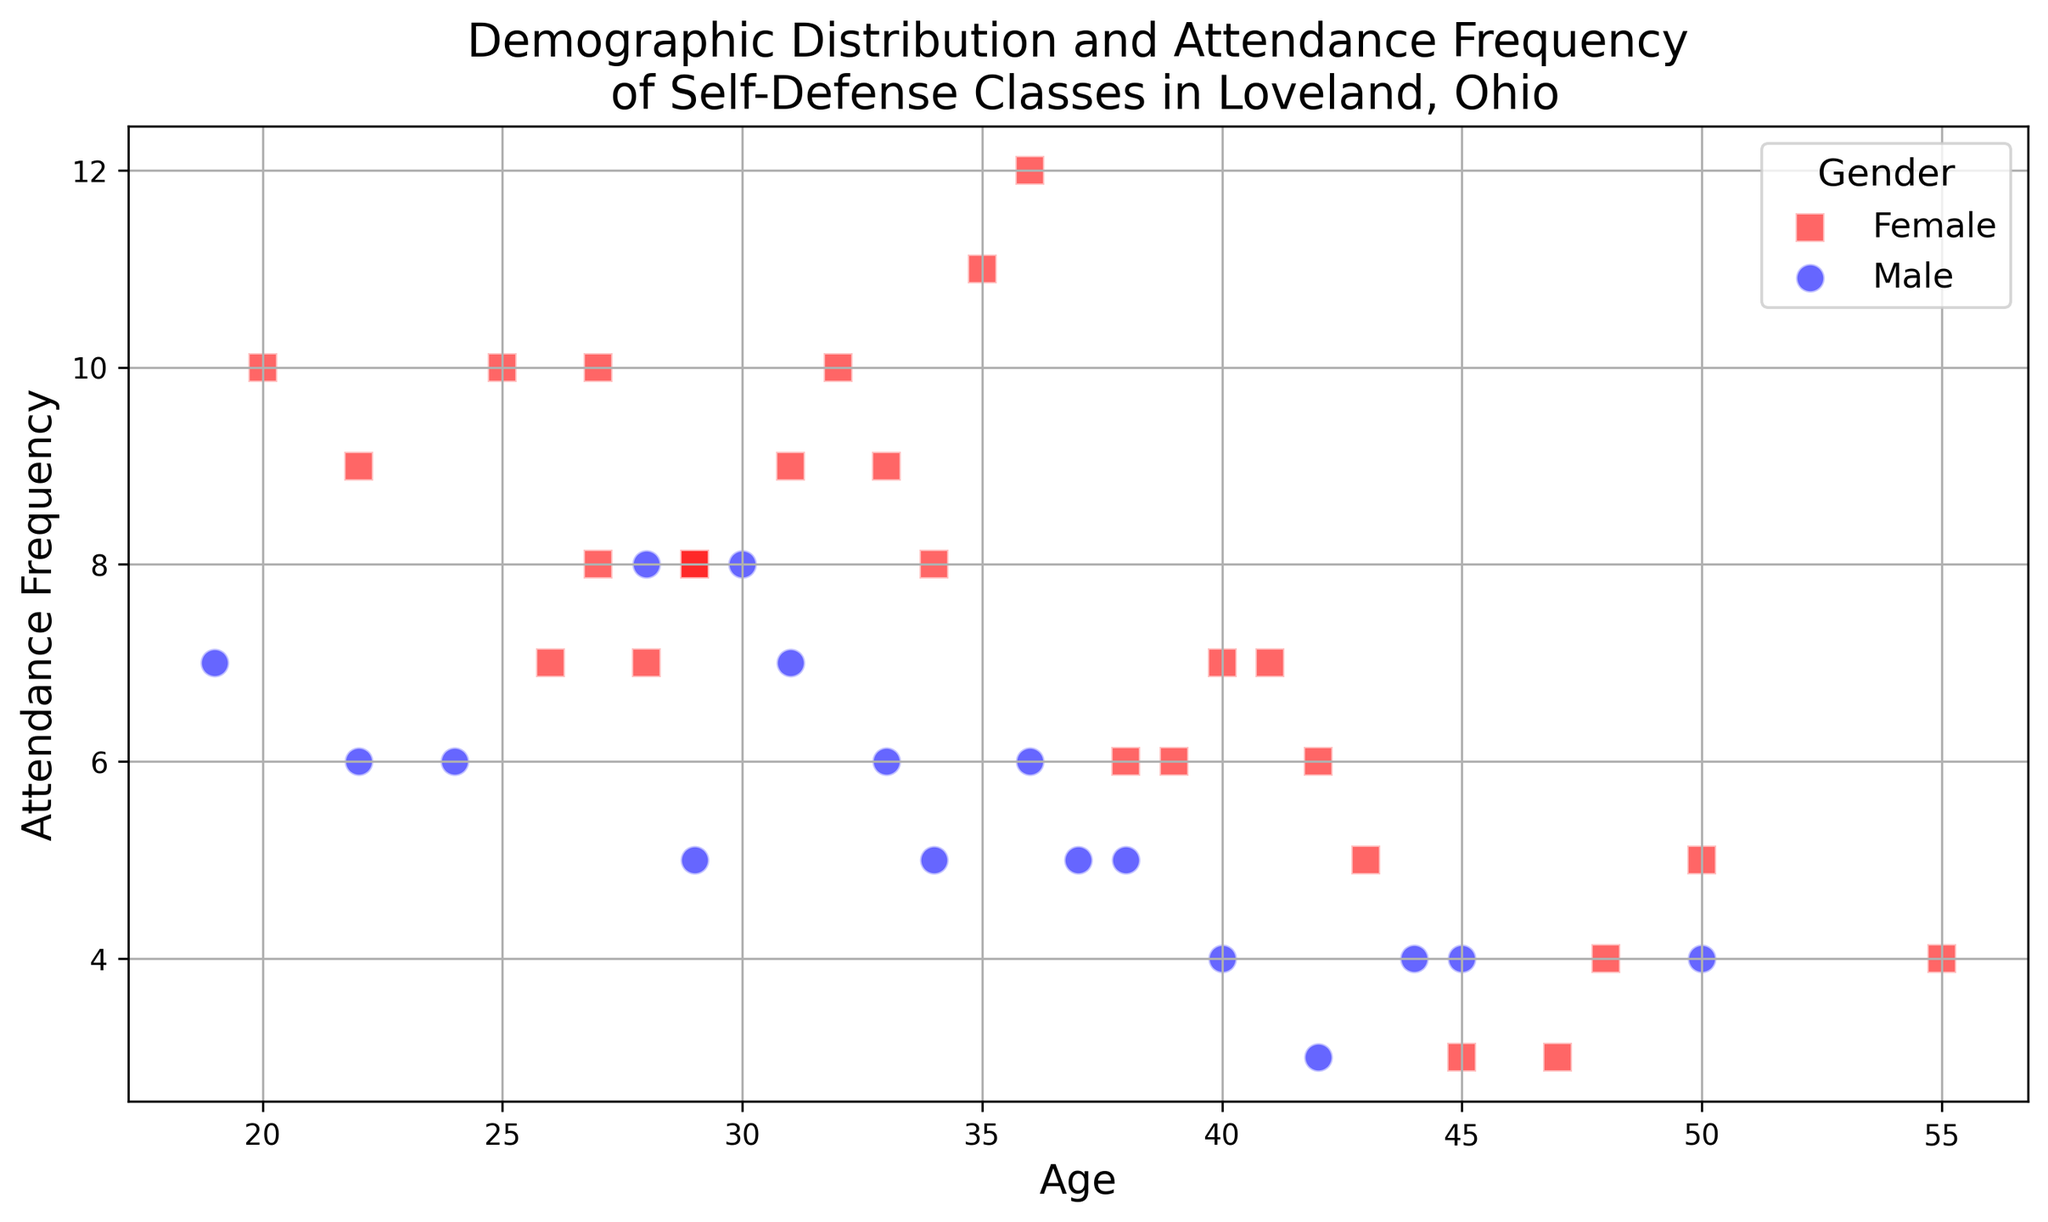What is the most common age range for females attending self-defense classes? By observing the plot, look for the range where most of the red square markers (indicating females) are clustered. Most red squares appear between ages 25 and 35.
Answer: 25-35 Which gender has a higher frequency of attending classes on average? Visually compare the positions of the red square markers (females) and the blue circle markers (males) on the y-axis. Red squares (females) tend to be higher on the y-axis compared to blue circles (males), indicating a higher frequency.
Answer: Female Among the attendees aged 40, which gender has the higher attendance frequency? At age 40, compare the position of the red square marker and the blue circle marker on the y-axis. The male (blue circle) has an attendance frequency of 4, while the female (red square) has 7.
Answer: Female What is the difference in attendance frequency between the youngest and the oldest male attendees? Identify the attendance frequencies of the youngest (age 19, 7 frequency) and the oldest (age 55, 4 frequency) males and calculate the difference. Difference = 7 - 4 = 3.
Answer: 3 What is the average attendance frequency for attendees aged 30? Identify all markers at age 30, which includes males and females, then average their attendance frequencies. There is one attendee aged 30 with a frequency of 8. So the average is 8.
Answer: 8 How many males attended classes 8 times? Count the number of blue circle markers positioned at y = 8. There are two males who attended classes 8 times (ages 28 and 30).
Answer: 2 At what age do females show the highest attendance frequency and what is that frequency? Look for the red square that is highest on the y-axis. It is at age 36, with an attendance frequency of 12.
Answer: 36, 12 Is there an age where both male and female attendees have the same attendance frequency? Look for any overlapping red squares and blue circles on the plot. At age 29, both genders have an attendance frequency of 8.
Answer: Yes, age 29, frequency 8 Which group has the least number of attendees with an attendance frequency of 3? Count the number of red squares and blue circles at y = 3. Only one male (age 42) and two females (ages 45 and 47) have a frequency of 3, so males have fewer.
Answer: Males What is the ratio of female to male attendees aged 36? Count the number of squares and circles at age 36. There is one blue circle (male) and one red square (female). The ratio of females to males is 1:1.
Answer: 1:1 